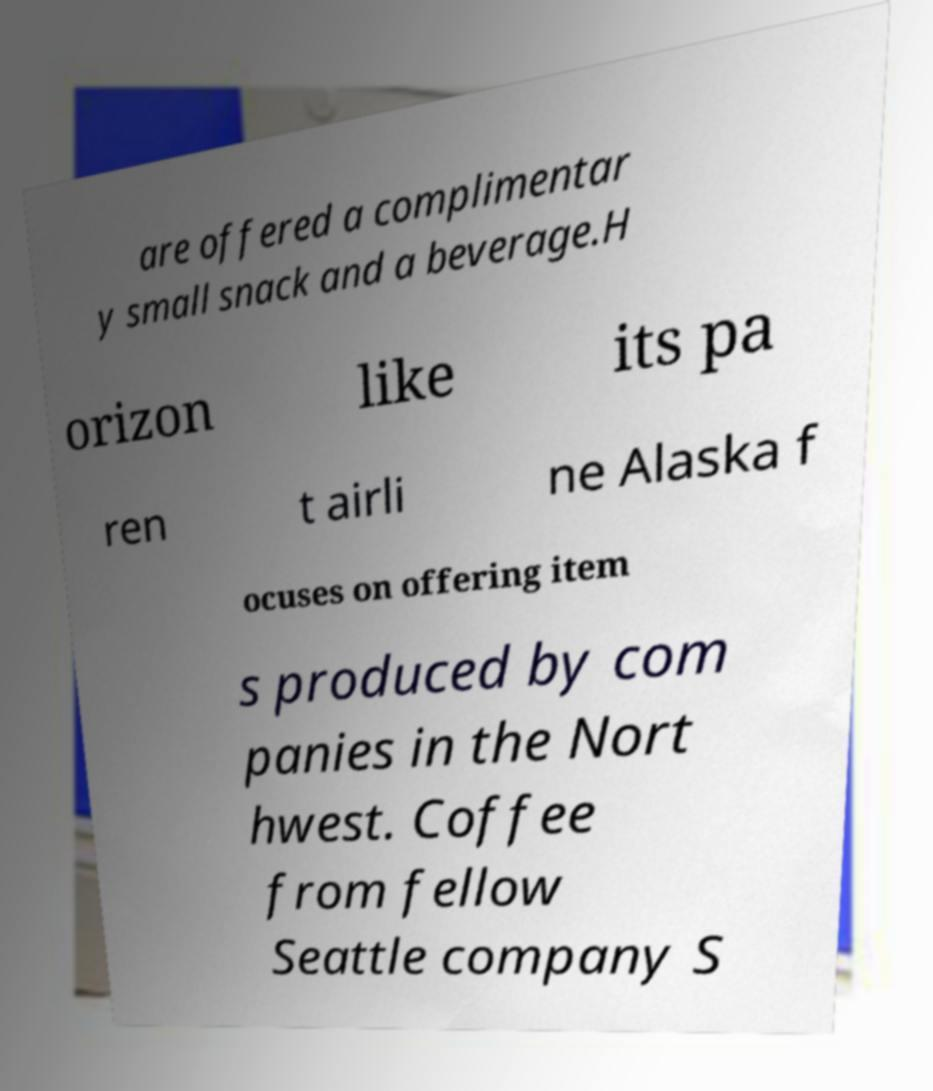Can you read and provide the text displayed in the image?This photo seems to have some interesting text. Can you extract and type it out for me? are offered a complimentar y small snack and a beverage.H orizon like its pa ren t airli ne Alaska f ocuses on offering item s produced by com panies in the Nort hwest. Coffee from fellow Seattle company S 